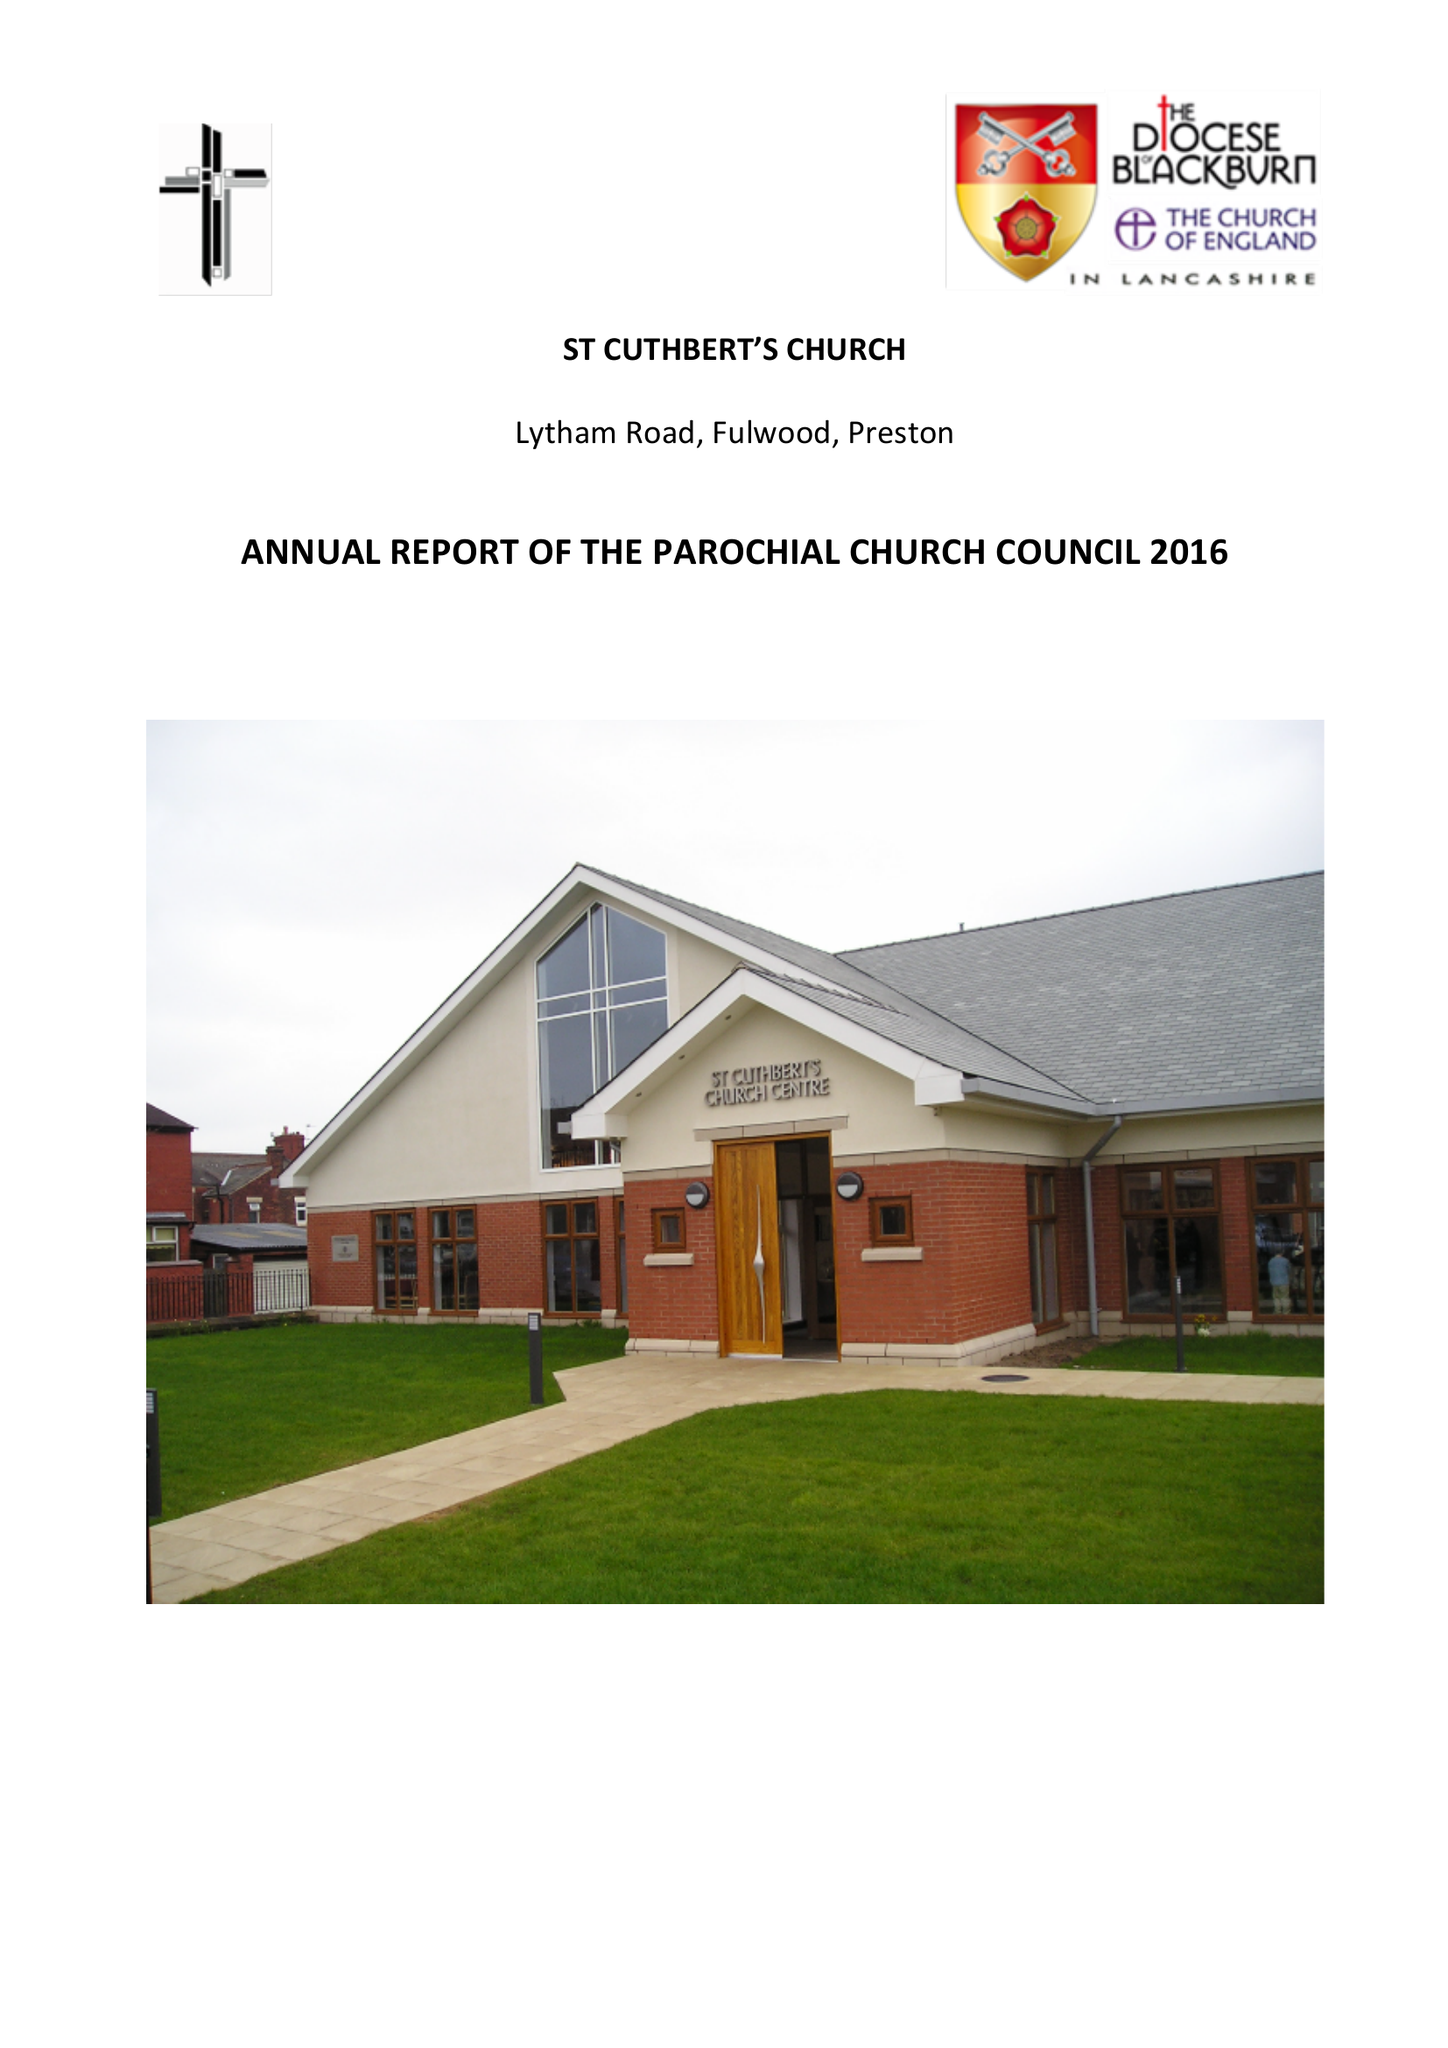What is the value for the address__post_town?
Answer the question using a single word or phrase. PRESTON 